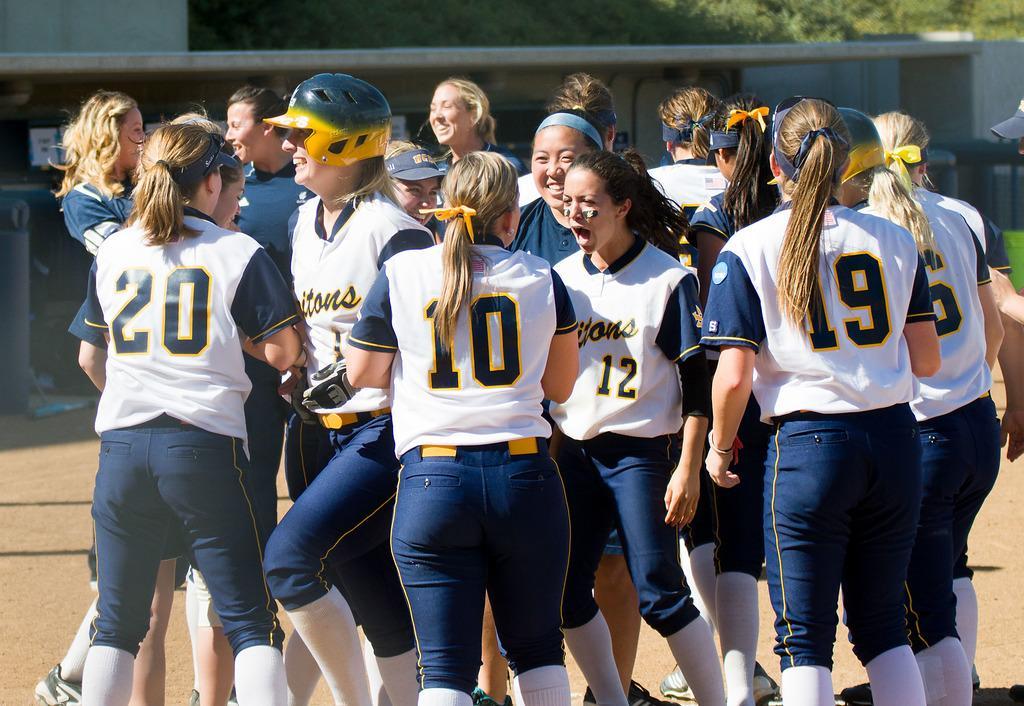Could you give a brief overview of what you see in this image? In this image I can see the group of people standing. These people are wearing the white and navy blue color jerseys and few people with helmets. These people are on the ground. In the back I can see many trees and the wall. 